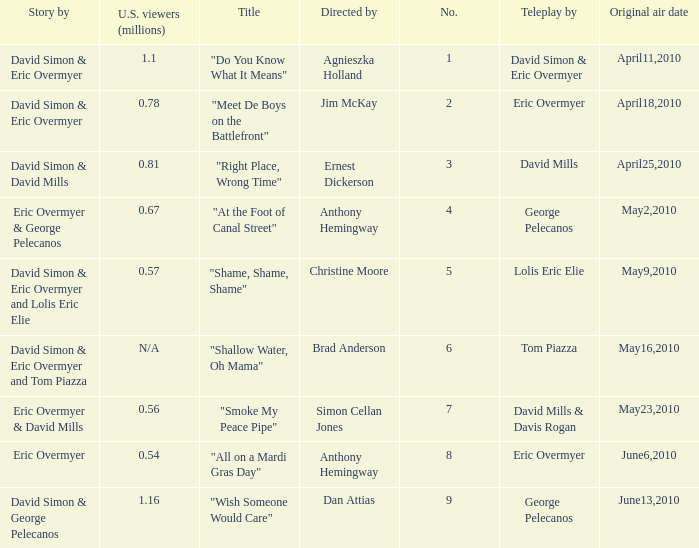Give me the full table as a dictionary. {'header': ['Story by', 'U.S. viewers (millions)', 'Title', 'Directed by', 'No.', 'Teleplay by', 'Original air date'], 'rows': [['David Simon & Eric Overmyer', '1.1', '"Do You Know What It Means"', 'Agnieszka Holland', '1', 'David Simon & Eric Overmyer', 'April11,2010'], ['David Simon & Eric Overmyer', '0.78', '"Meet De Boys on the Battlefront"', 'Jim McKay', '2', 'Eric Overmyer', 'April18,2010'], ['David Simon & David Mills', '0.81', '"Right Place, Wrong Time"', 'Ernest Dickerson', '3', 'David Mills', 'April25,2010'], ['Eric Overmyer & George Pelecanos', '0.67', '"At the Foot of Canal Street"', 'Anthony Hemingway', '4', 'George Pelecanos', 'May2,2010'], ['David Simon & Eric Overmyer and Lolis Eric Elie', '0.57', '"Shame, Shame, Shame"', 'Christine Moore', '5', 'Lolis Eric Elie', 'May9,2010'], ['David Simon & Eric Overmyer and Tom Piazza', 'N/A', '"Shallow Water, Oh Mama"', 'Brad Anderson', '6', 'Tom Piazza', 'May16,2010'], ['Eric Overmyer & David Mills', '0.56', '"Smoke My Peace Pipe"', 'Simon Cellan Jones', '7', 'David Mills & Davis Rogan', 'May23,2010'], ['Eric Overmyer', '0.54', '"All on a Mardi Gras Day"', 'Anthony Hemingway', '8', 'Eric Overmyer', 'June6,2010'], ['David Simon & George Pelecanos', '1.16', '"Wish Someone Would Care"', 'Dan Attias', '9', 'George Pelecanos', 'June13,2010']]} Name the us viewers directed by christine moore 0.57. 